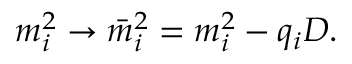<formula> <loc_0><loc_0><loc_500><loc_500>m _ { i } ^ { 2 } \rightarrow \bar { m } _ { i } ^ { 2 } = m _ { i } ^ { 2 } - q _ { i } D .</formula> 